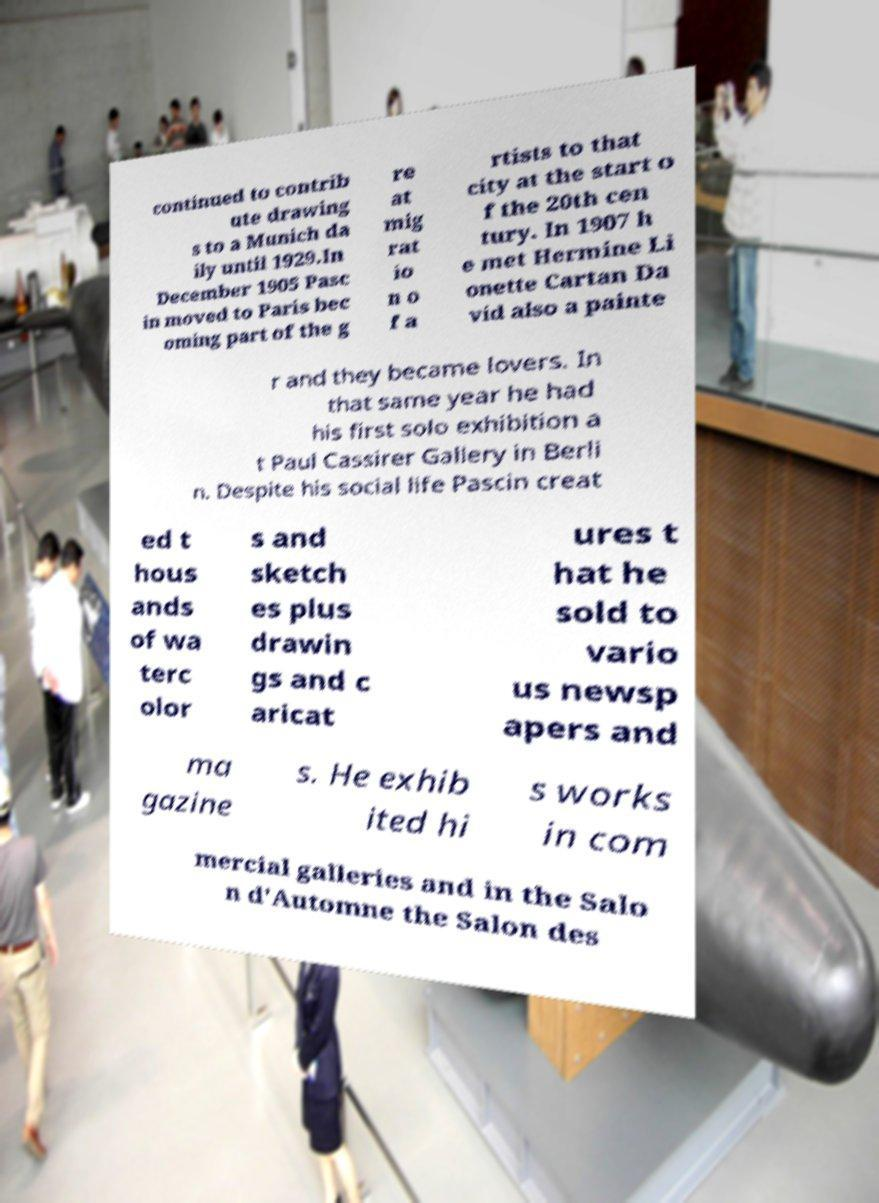For documentation purposes, I need the text within this image transcribed. Could you provide that? continued to contrib ute drawing s to a Munich da ily until 1929.In December 1905 Pasc in moved to Paris bec oming part of the g re at mig rat io n o f a rtists to that city at the start o f the 20th cen tury. In 1907 h e met Hermine Li onette Cartan Da vid also a painte r and they became lovers. In that same year he had his first solo exhibition a t Paul Cassirer Gallery in Berli n. Despite his social life Pascin creat ed t hous ands of wa terc olor s and sketch es plus drawin gs and c aricat ures t hat he sold to vario us newsp apers and ma gazine s. He exhib ited hi s works in com mercial galleries and in the Salo n d'Automne the Salon des 